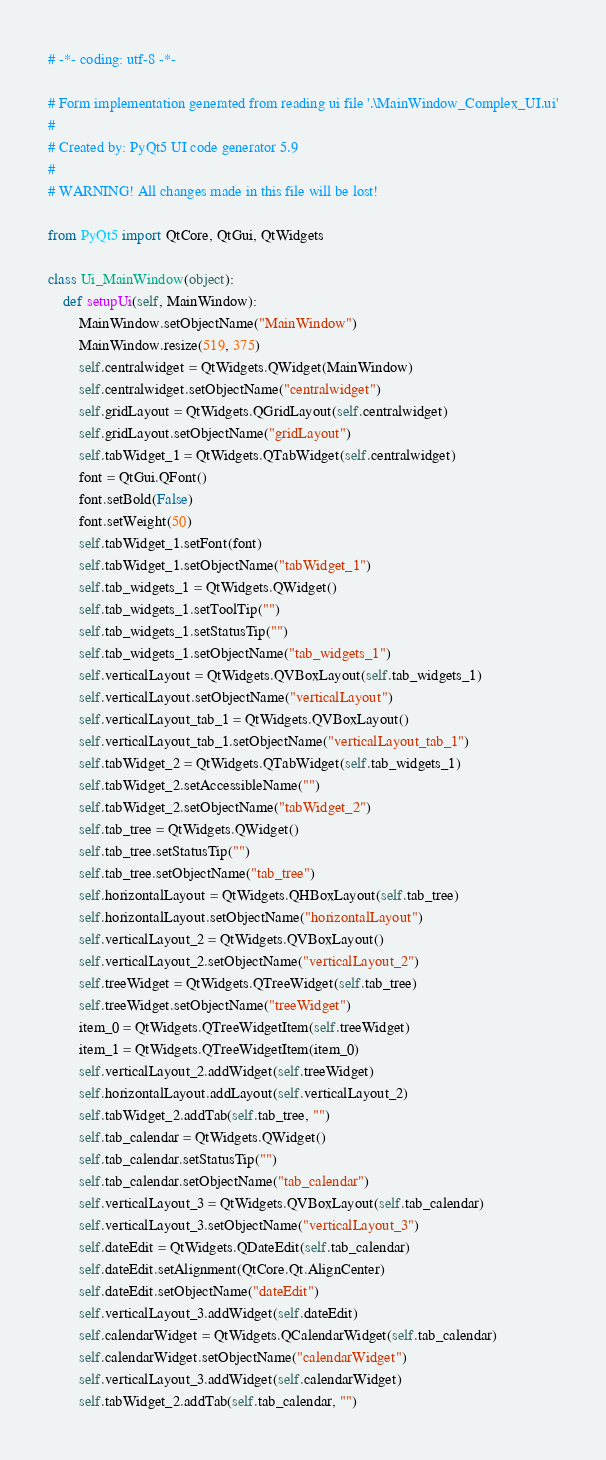Convert code to text. <code><loc_0><loc_0><loc_500><loc_500><_Python_># -*- coding: utf-8 -*-

# Form implementation generated from reading ui file '.\MainWindow_Complex_UI.ui'
#
# Created by: PyQt5 UI code generator 5.9
#
# WARNING! All changes made in this file will be lost!

from PyQt5 import QtCore, QtGui, QtWidgets

class Ui_MainWindow(object):
    def setupUi(self, MainWindow):
        MainWindow.setObjectName("MainWindow")
        MainWindow.resize(519, 375)
        self.centralwidget = QtWidgets.QWidget(MainWindow)
        self.centralwidget.setObjectName("centralwidget")
        self.gridLayout = QtWidgets.QGridLayout(self.centralwidget)
        self.gridLayout.setObjectName("gridLayout")
        self.tabWidget_1 = QtWidgets.QTabWidget(self.centralwidget)
        font = QtGui.QFont()
        font.setBold(False)
        font.setWeight(50)
        self.tabWidget_1.setFont(font)
        self.tabWidget_1.setObjectName("tabWidget_1")
        self.tab_widgets_1 = QtWidgets.QWidget()
        self.tab_widgets_1.setToolTip("")
        self.tab_widgets_1.setStatusTip("")
        self.tab_widgets_1.setObjectName("tab_widgets_1")
        self.verticalLayout = QtWidgets.QVBoxLayout(self.tab_widgets_1)
        self.verticalLayout.setObjectName("verticalLayout")
        self.verticalLayout_tab_1 = QtWidgets.QVBoxLayout()
        self.verticalLayout_tab_1.setObjectName("verticalLayout_tab_1")
        self.tabWidget_2 = QtWidgets.QTabWidget(self.tab_widgets_1)
        self.tabWidget_2.setAccessibleName("")
        self.tabWidget_2.setObjectName("tabWidget_2")
        self.tab_tree = QtWidgets.QWidget()
        self.tab_tree.setStatusTip("")
        self.tab_tree.setObjectName("tab_tree")
        self.horizontalLayout = QtWidgets.QHBoxLayout(self.tab_tree)
        self.horizontalLayout.setObjectName("horizontalLayout")
        self.verticalLayout_2 = QtWidgets.QVBoxLayout()
        self.verticalLayout_2.setObjectName("verticalLayout_2")
        self.treeWidget = QtWidgets.QTreeWidget(self.tab_tree)
        self.treeWidget.setObjectName("treeWidget")
        item_0 = QtWidgets.QTreeWidgetItem(self.treeWidget)
        item_1 = QtWidgets.QTreeWidgetItem(item_0)
        self.verticalLayout_2.addWidget(self.treeWidget)
        self.horizontalLayout.addLayout(self.verticalLayout_2)
        self.tabWidget_2.addTab(self.tab_tree, "")
        self.tab_calendar = QtWidgets.QWidget()
        self.tab_calendar.setStatusTip("")
        self.tab_calendar.setObjectName("tab_calendar")
        self.verticalLayout_3 = QtWidgets.QVBoxLayout(self.tab_calendar)
        self.verticalLayout_3.setObjectName("verticalLayout_3")
        self.dateEdit = QtWidgets.QDateEdit(self.tab_calendar)
        self.dateEdit.setAlignment(QtCore.Qt.AlignCenter)
        self.dateEdit.setObjectName("dateEdit")
        self.verticalLayout_3.addWidget(self.dateEdit)
        self.calendarWidget = QtWidgets.QCalendarWidget(self.tab_calendar)
        self.calendarWidget.setObjectName("calendarWidget")
        self.verticalLayout_3.addWidget(self.calendarWidget)
        self.tabWidget_2.addTab(self.tab_calendar, "")</code> 